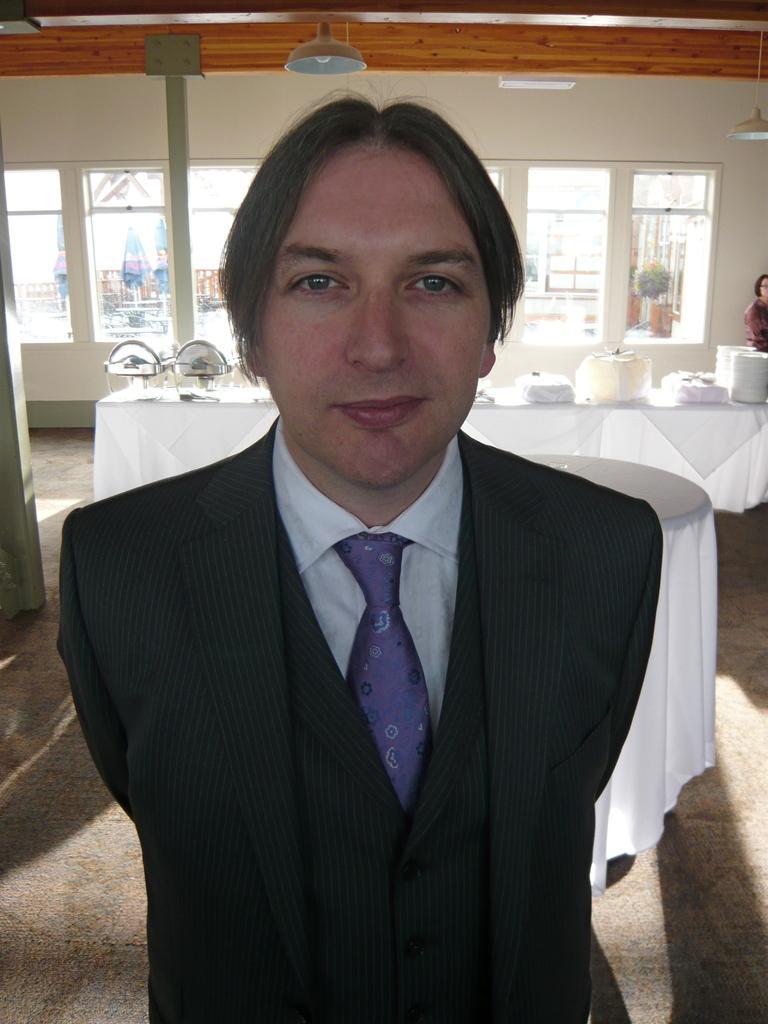Can you describe this image briefly? In this image we can see a man standing on the floor. He is wearing a suit and a tie. Here we can see a table which is covered with a white cloth. In the background, we can see the tables which are covered with white cloth. Here we can see the plates and stainless steel dish bowls on the table. Here we can see a woman on the right side. In the background, we can see the glass window. Here we can see the lighting arrangement on the roof. 